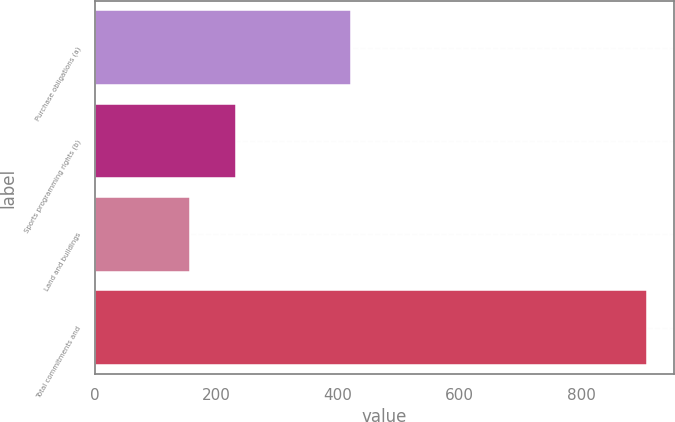Convert chart to OTSL. <chart><loc_0><loc_0><loc_500><loc_500><bar_chart><fcel>Purchase obligations (a)<fcel>Sports programming rights (b)<fcel>Land and buildings<fcel>Total commitments and<nl><fcel>422<fcel>232.1<fcel>157<fcel>908<nl></chart> 